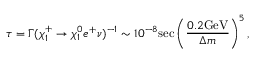<formula> <loc_0><loc_0><loc_500><loc_500>\tau = \Gamma ( \chi _ { 1 } ^ { + } \rightarrow \chi _ { 1 } ^ { 0 } e ^ { + } \nu ) ^ { - 1 } \sim 1 0 ^ { - 8 } s e c \left ( \frac { 0 . 2 G e V } { \Delta m } \right ) ^ { 5 } ,</formula> 